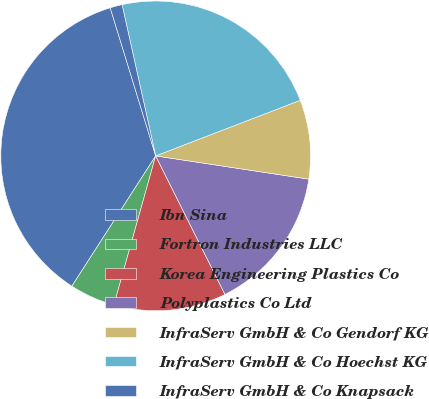<chart> <loc_0><loc_0><loc_500><loc_500><pie_chart><fcel>Ibn Sina<fcel>Fortron Industries LLC<fcel>Korea Engineering Plastics Co<fcel>Polyplastics Co Ltd<fcel>InfraServ GmbH & Co Gendorf KG<fcel>InfraServ GmbH & Co Hoechst KG<fcel>InfraServ GmbH & Co Knapsack<nl><fcel>36.16%<fcel>4.75%<fcel>11.73%<fcel>15.22%<fcel>8.24%<fcel>22.64%<fcel>1.26%<nl></chart> 